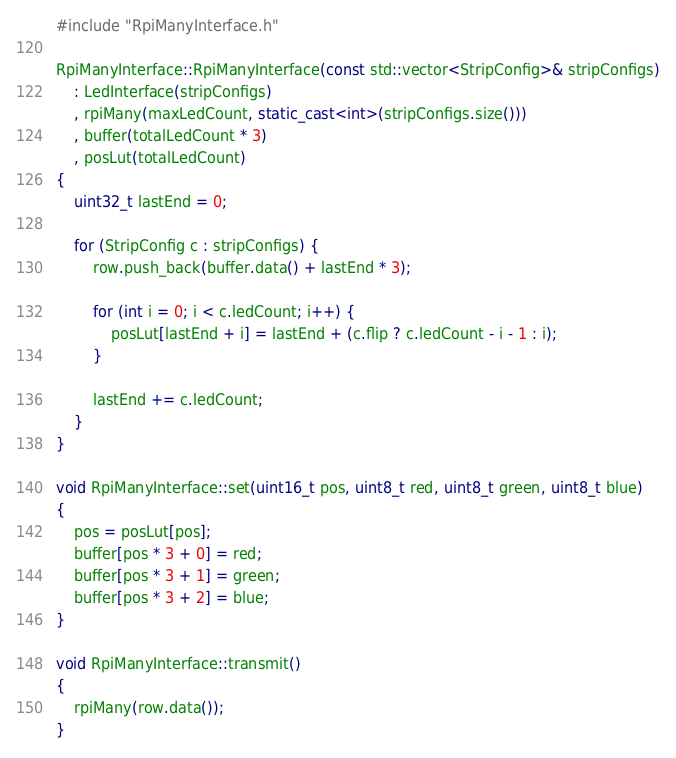<code> <loc_0><loc_0><loc_500><loc_500><_C++_>#include "RpiManyInterface.h"

RpiManyInterface::RpiManyInterface(const std::vector<StripConfig>& stripConfigs)
	: LedInterface(stripConfigs)
	, rpiMany(maxLedCount, static_cast<int>(stripConfigs.size()))
	, buffer(totalLedCount * 3)
	, posLut(totalLedCount)
{
	uint32_t lastEnd = 0;

	for (StripConfig c : stripConfigs) {
		row.push_back(buffer.data() + lastEnd * 3);

		for (int i = 0; i < c.ledCount; i++) {
			posLut[lastEnd + i] = lastEnd + (c.flip ? c.ledCount - i - 1 : i);
		}

		lastEnd += c.ledCount;
	}
}

void RpiManyInterface::set(uint16_t pos, uint8_t red, uint8_t green, uint8_t blue)
{
	pos = posLut[pos];
	buffer[pos * 3 + 0] = red;
	buffer[pos * 3 + 1] = green;
	buffer[pos * 3 + 2] = blue;
}

void RpiManyInterface::transmit()
{
	rpiMany(row.data());
}
</code> 